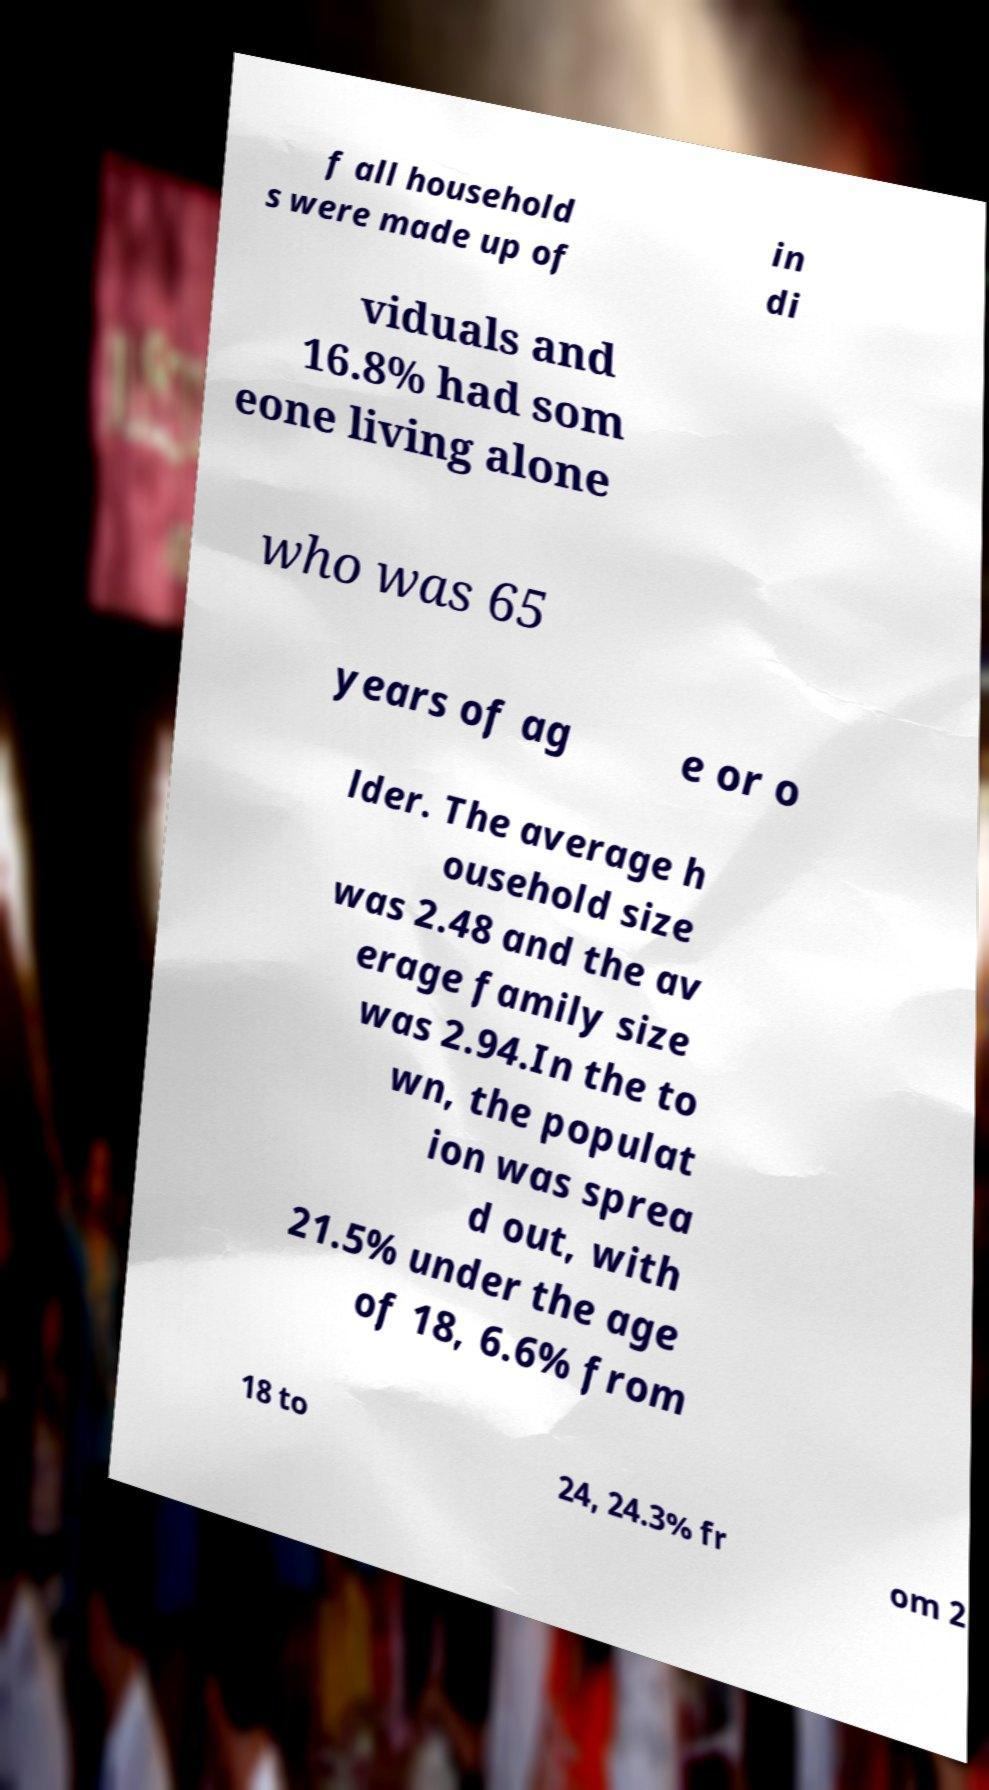For documentation purposes, I need the text within this image transcribed. Could you provide that? f all household s were made up of in di viduals and 16.8% had som eone living alone who was 65 years of ag e or o lder. The average h ousehold size was 2.48 and the av erage family size was 2.94.In the to wn, the populat ion was sprea d out, with 21.5% under the age of 18, 6.6% from 18 to 24, 24.3% fr om 2 